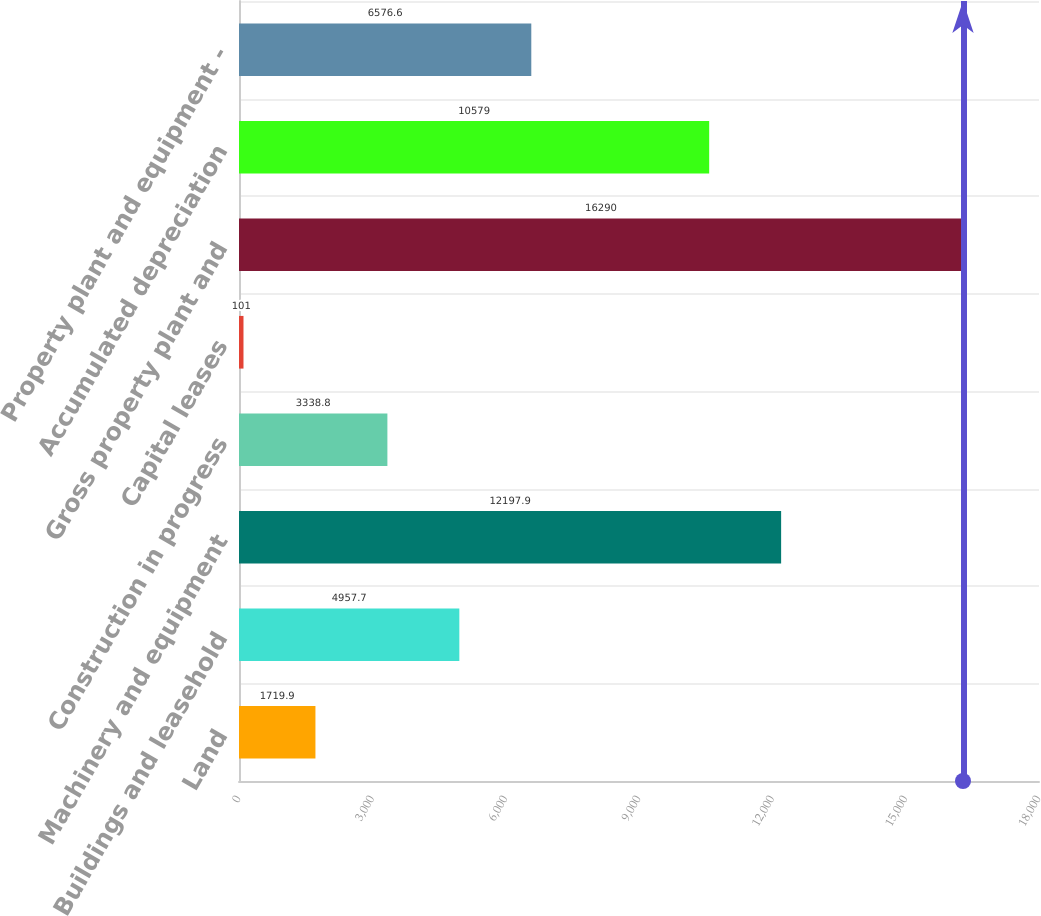Convert chart. <chart><loc_0><loc_0><loc_500><loc_500><bar_chart><fcel>Land<fcel>Buildings and leasehold<fcel>Machinery and equipment<fcel>Construction in progress<fcel>Capital leases<fcel>Gross property plant and<fcel>Accumulated depreciation<fcel>Property plant and equipment -<nl><fcel>1719.9<fcel>4957.7<fcel>12197.9<fcel>3338.8<fcel>101<fcel>16290<fcel>10579<fcel>6576.6<nl></chart> 